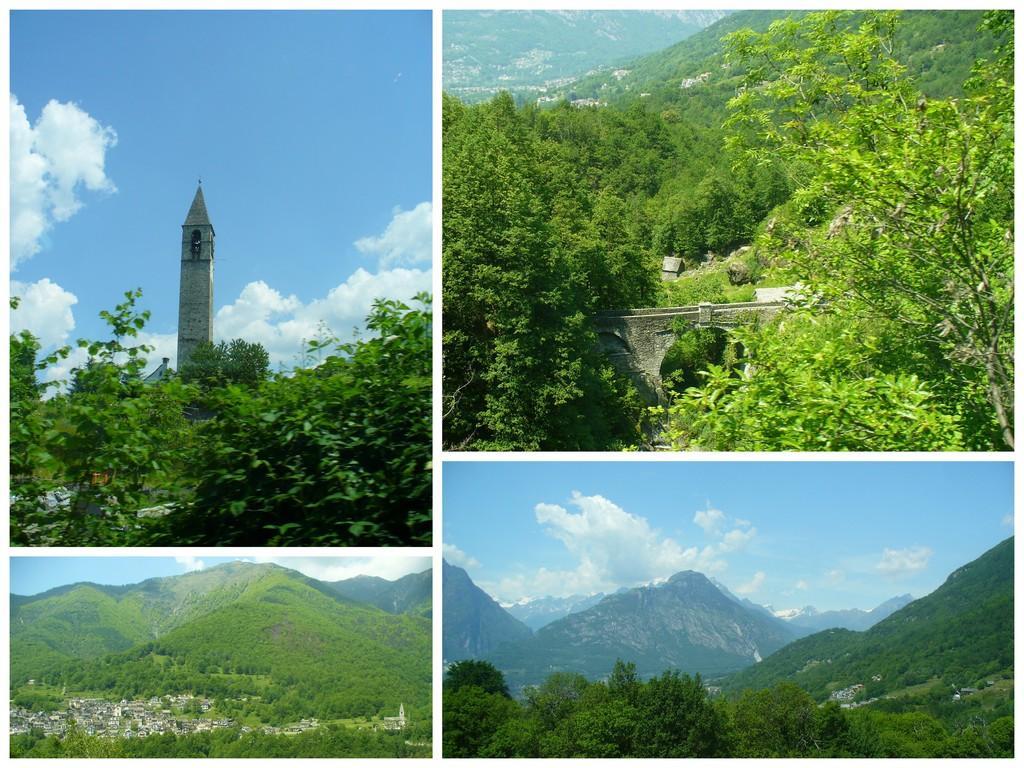How would you summarize this image in a sentence or two? Here the college is there. In first image we can see a tower, tree and sky with some cloud. In the second image mountains is there with trees.. In third and fourth image mountains with full of greenery is present. 